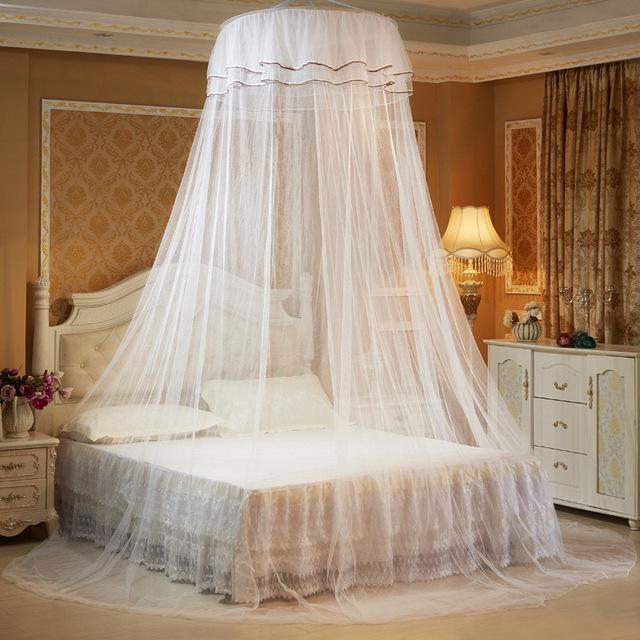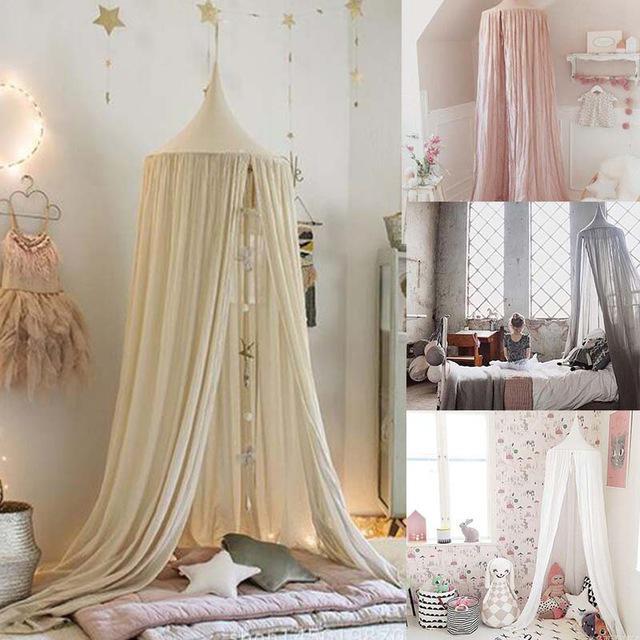The first image is the image on the left, the second image is the image on the right. Assess this claim about the two images: "Each image shows a gauzy canopy that drapes from a round shape suspended from the ceiling, but the left image features a white canopy while the right image features an off-white canopy.". Correct or not? Answer yes or no. Yes. 